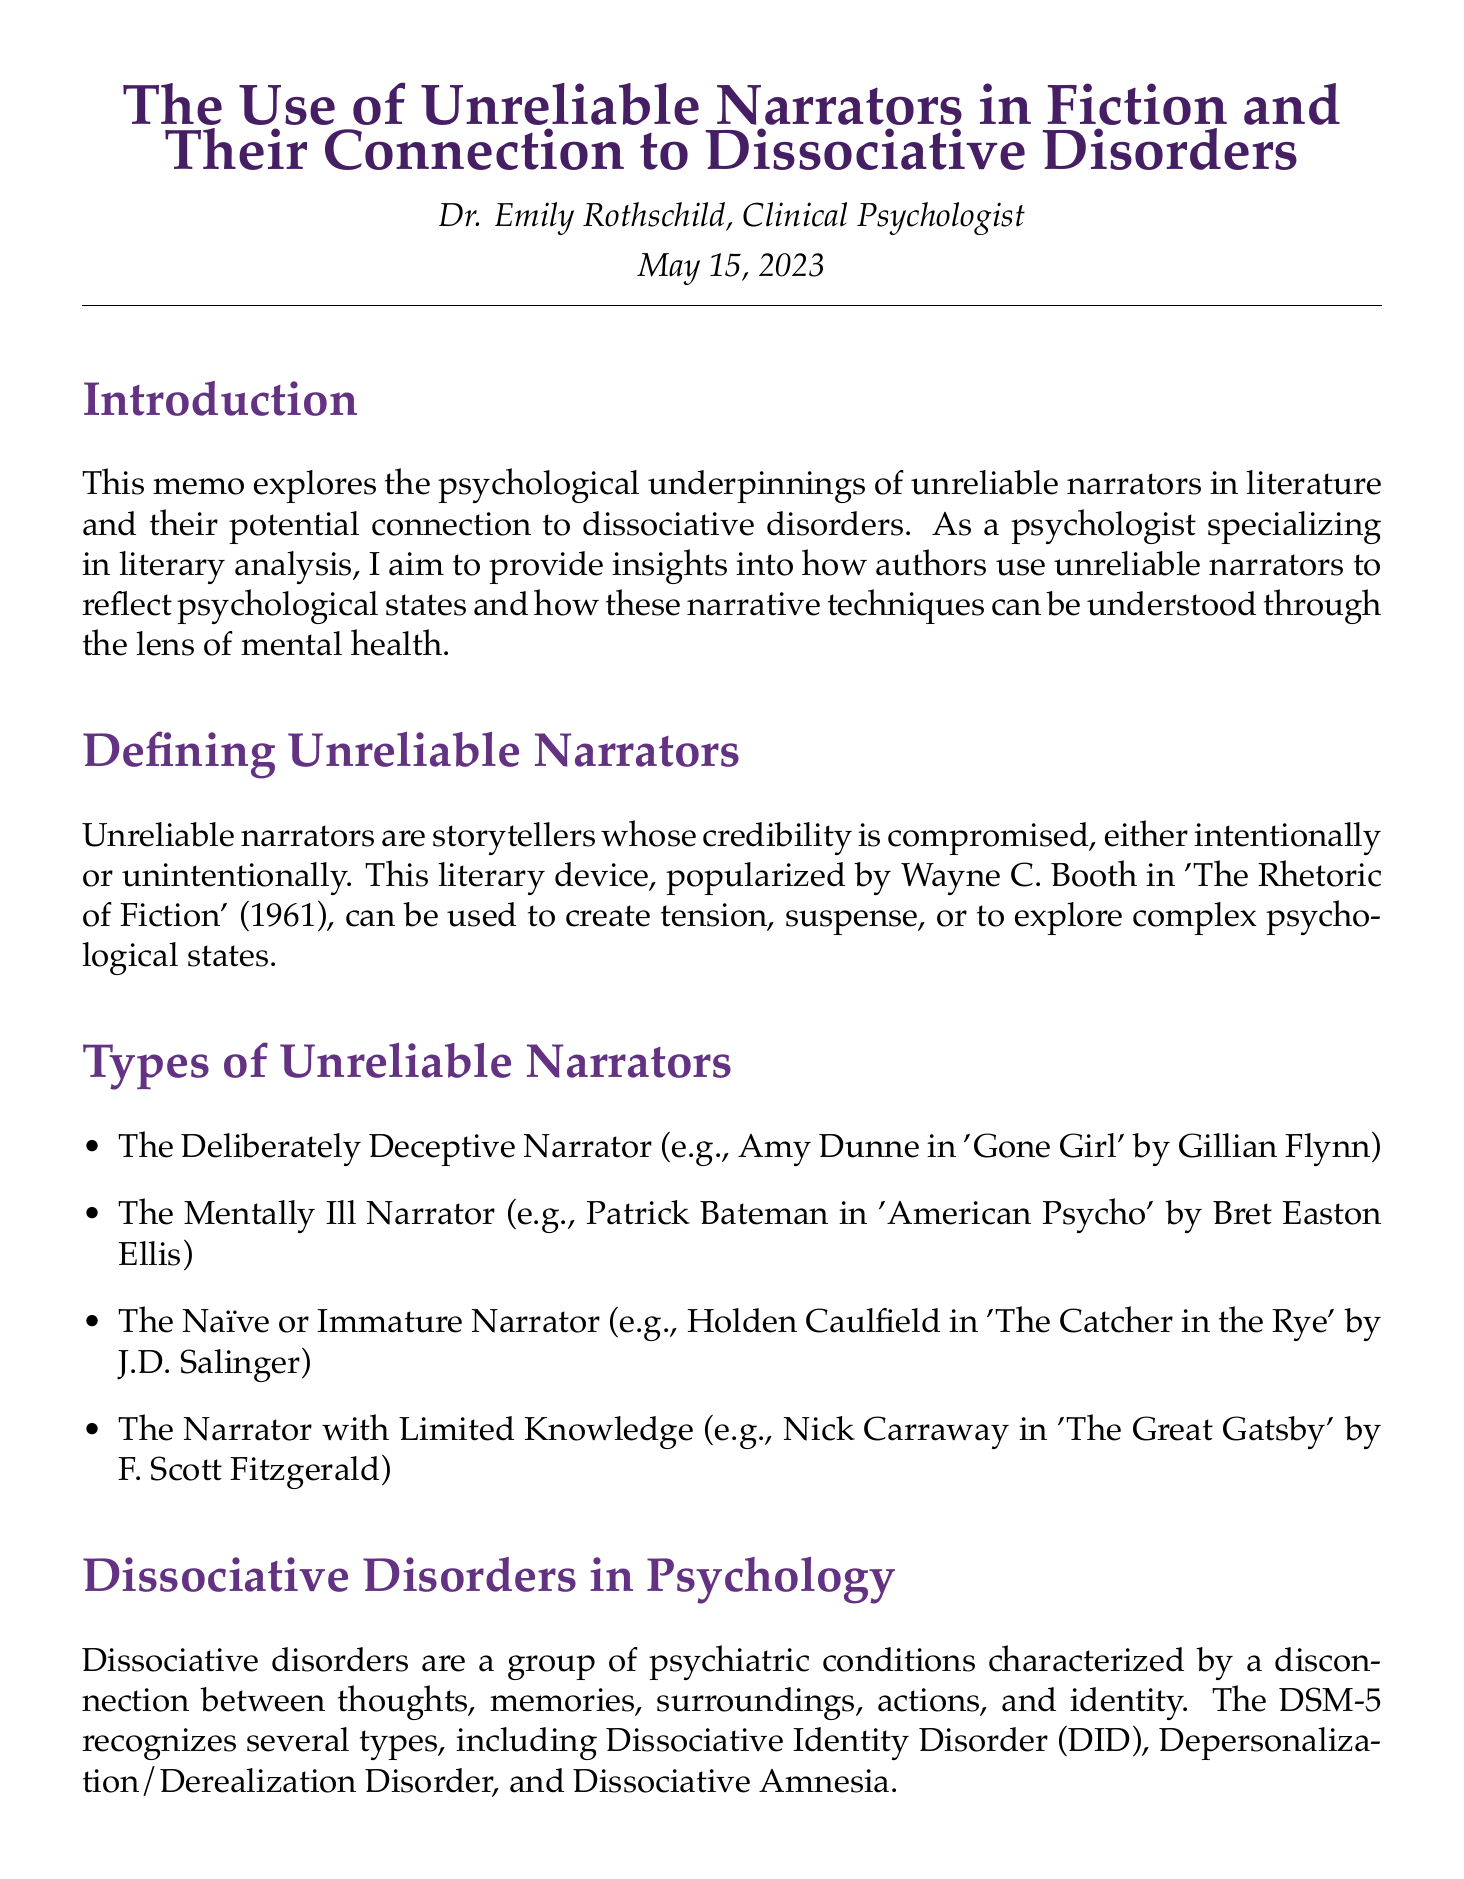what is the title of the memo? The title of the memo is presented at the beginning, indicating its main focus on unreliable narrators and dissociative disorders.
Answer: The Use of Unreliable Narrators in Fiction and Their Connection to Dissociative Disorders who is the author of the memo? The author's name is provided just below the title, indicating their credentials and role.
Answer: Dr. Emily Rothschild, Clinical Psychologist what date was the memo written? The date is listed beneath the author's name, marking when the memo was published.
Answer: May 15, 2023 which character represents a deliberately deceptive narrator? The examples in the section on types of unreliable narrators explicitly include characters representing this classification.
Answer: Amy Dunne in 'Gone Girl' by Gillian Flynn how many types of dissociative disorders are recognized by the DSM-5? The section on dissociative disorders mentions that the DSM-5 recognizes several types, specifically highlighting them.
Answer: three what does the fragmented narrative structure mirror? The connections made between narrative structure and psychological conditions indicate what the fragmented narrative represents.
Answer: the fragmented sense of self in DID name a case study analyzed in the memo. The memo includes specific case studies, one of which is explicitly named in the respective section.
Answer: 'Fight Club' by Chuck Palahniuk what psychological state does "The Yellow Wallpaper" reflect? The analysis of the protagonist's experiences in this case study mentions specific psychological experiences reflected in the narrative.
Answer: elements of depersonalization and derealization what is a key implication of understanding unreliable narrators? The implications section outlines how understanding these narratives relates to literary analysis and empathy in mental health.
Answer: foster empathy for individuals with dissociative disorders 